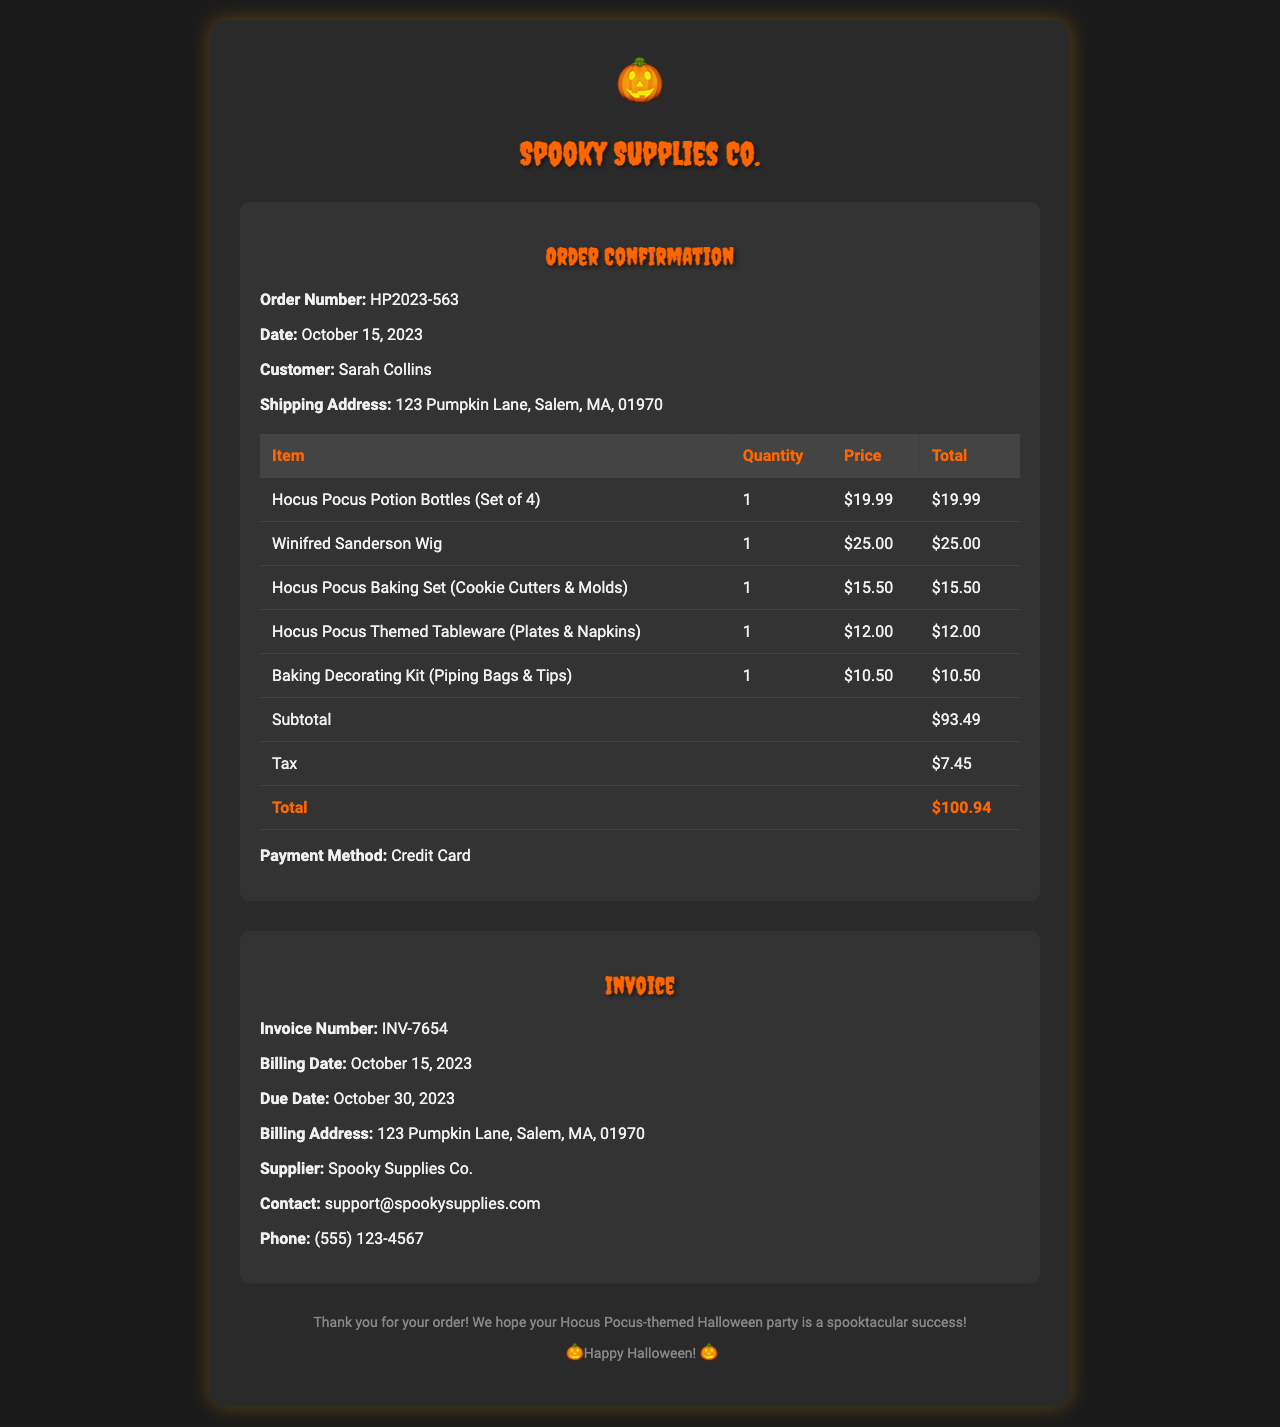What is the order number? The order number is a unique identifier for the order, which is specified in the document.
Answer: HP2023-563 What is the total amount charged? The total amount charged is calculated by adding the subtotal and tax provided in the document.
Answer: $100.94 What date was the order placed? The order date is clearly mentioned in the document near the order details section.
Answer: October 15, 2023 Who is the customer? The customer's name is provided in the order details section of the document.
Answer: Sarah Collins What is the email contact for the supplier? The document lists a contact email for the supplier in the invoice details section.
Answer: support@spookysupplies.com How much was charged for the Winifred Sanderson wig? The price for that specific item is included in the itemized list of the order.
Answer: $25.00 What is the due date for the invoice? The due date for payment is specified under the invoice details section in the document.
Answer: October 30, 2023 What items are included for baking? The baking-related items are identified in the list of items purchased in the order details.
Answer: Hocus Pocus Baking Set (Cookie Cutters & Molds), Baking Decorating Kit (Piping Bags & Tips) 